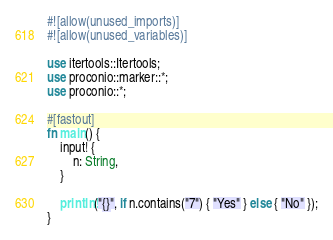<code> <loc_0><loc_0><loc_500><loc_500><_Rust_>#![allow(unused_imports)]
#![allow(unused_variables)]

use itertools::Itertools;
use proconio::marker::*;
use proconio::*;

#[fastout]
fn main() {
    input! {
        n: String,
    }

    println!("{}", if n.contains("7") { "Yes" } else { "No" });
}
</code> 